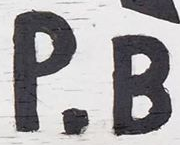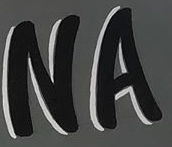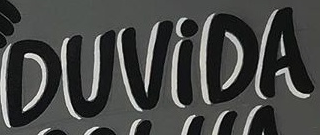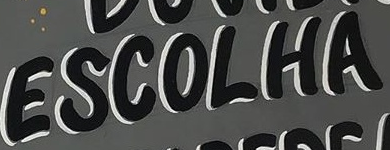Read the text from these images in sequence, separated by a semicolon. P.B; NA; DUViDA; ESCOLHA 